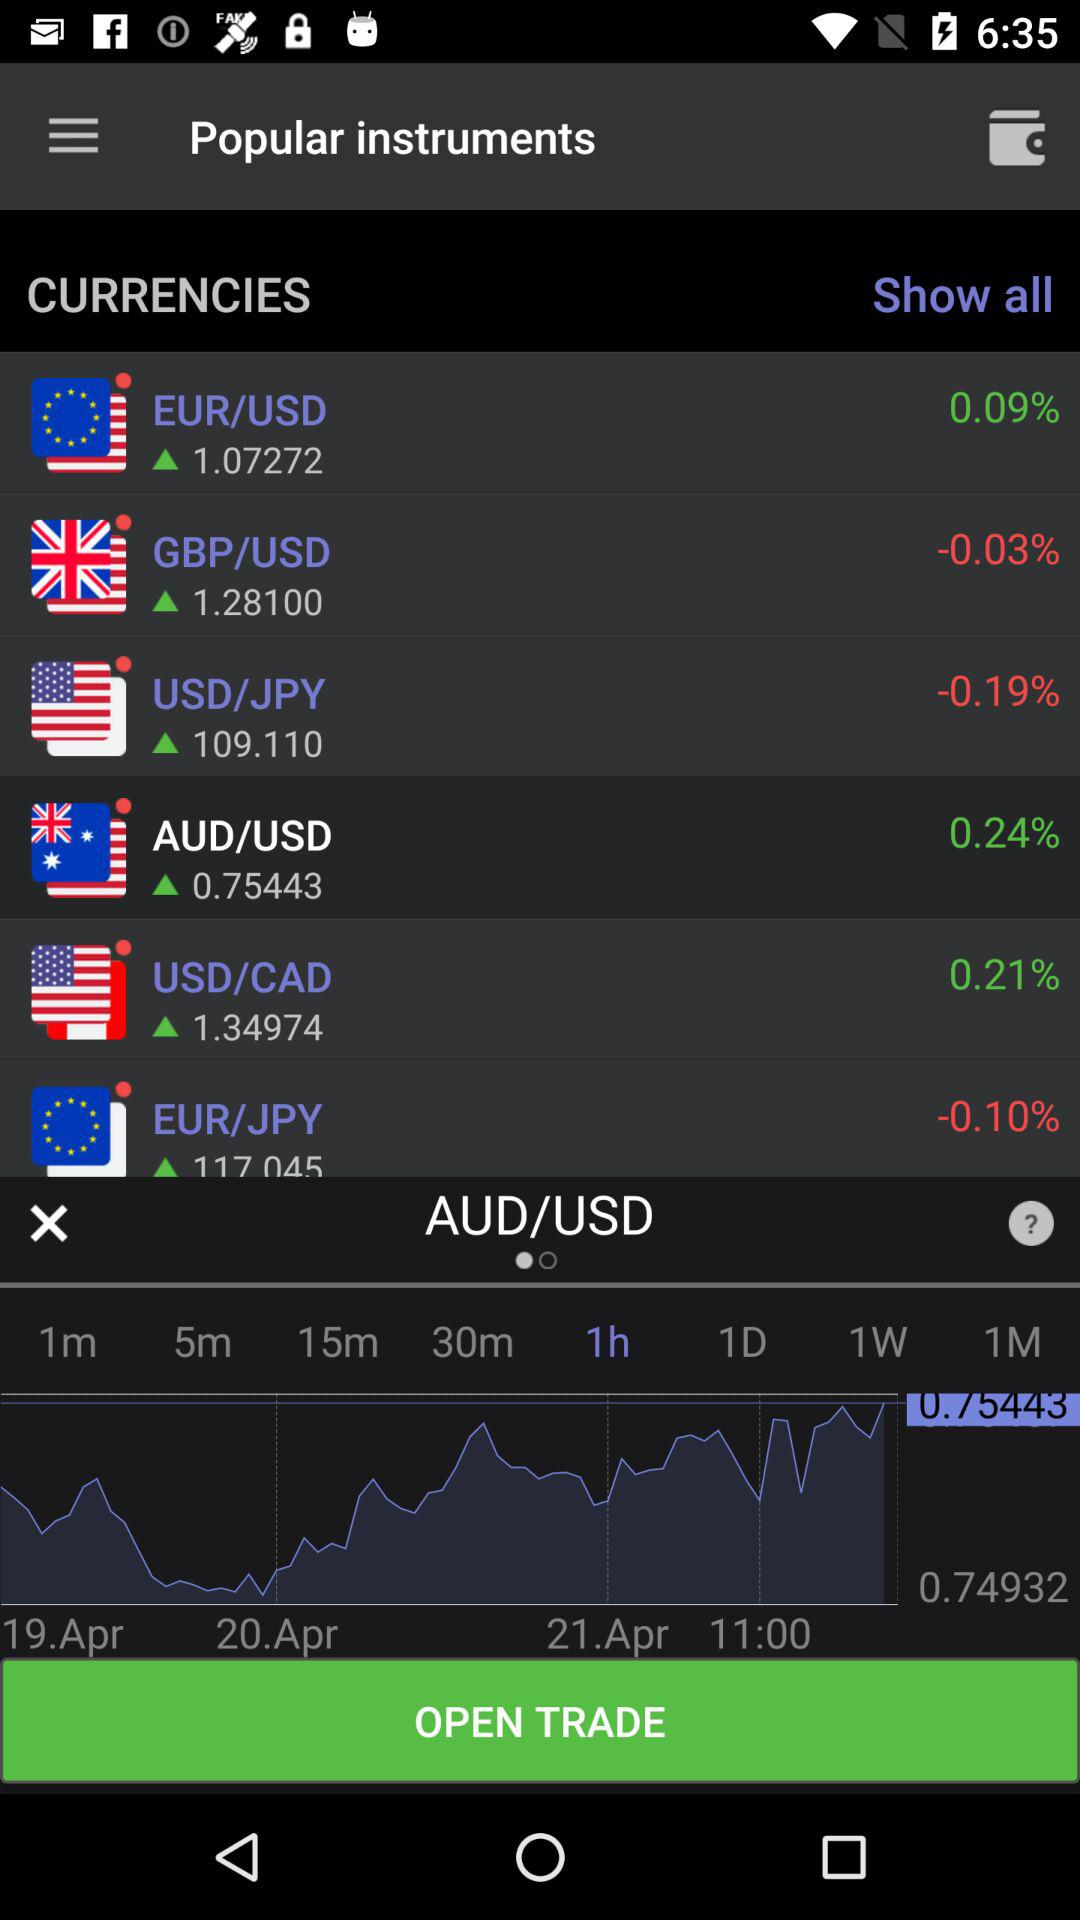What is the percentage change of the AUD/USD price compared to the previous day?
Answer the question using a single word or phrase. 0.24% 